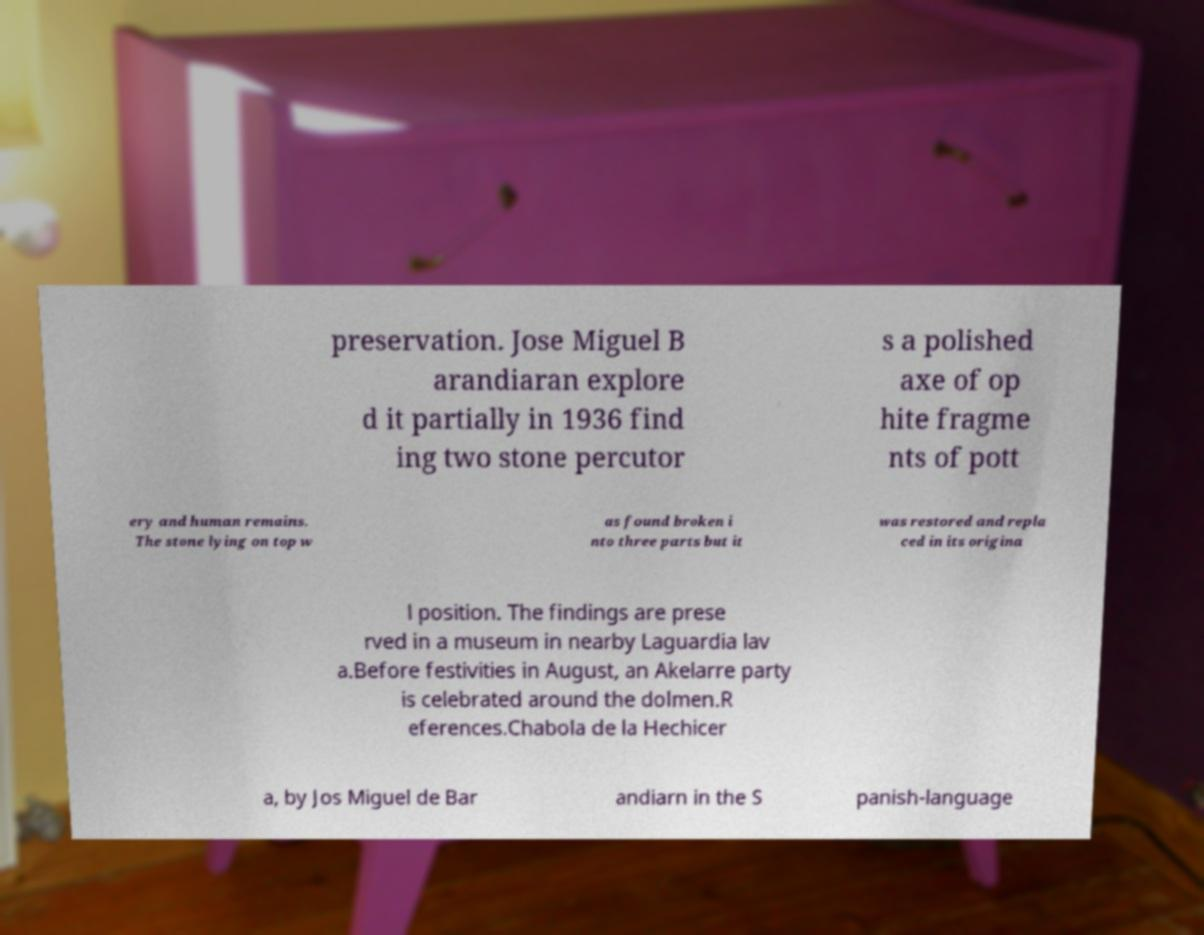What messages or text are displayed in this image? I need them in a readable, typed format. preservation. Jose Miguel B arandiaran explore d it partially in 1936 find ing two stone percutor s a polished axe of op hite fragme nts of pott ery and human remains. The stone lying on top w as found broken i nto three parts but it was restored and repla ced in its origina l position. The findings are prese rved in a museum in nearby Laguardia lav a.Before festivities in August, an Akelarre party is celebrated around the dolmen.R eferences.Chabola de la Hechicer a, by Jos Miguel de Bar andiarn in the S panish-language 